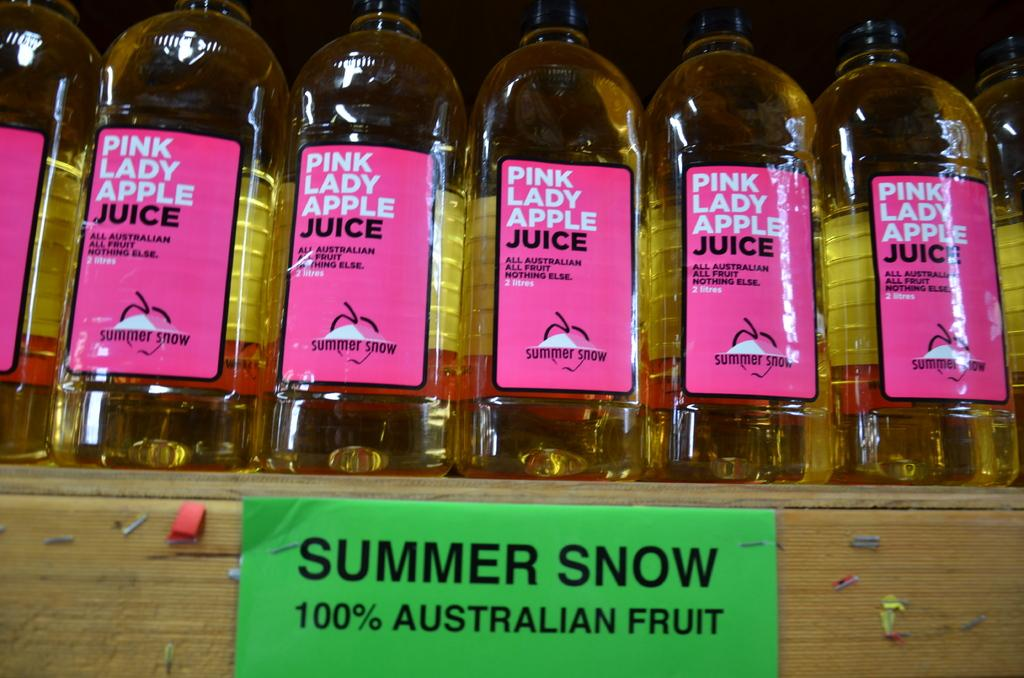<image>
Relay a brief, clear account of the picture shown. Bottles of Pink Lady apple juice are on a shelf. 